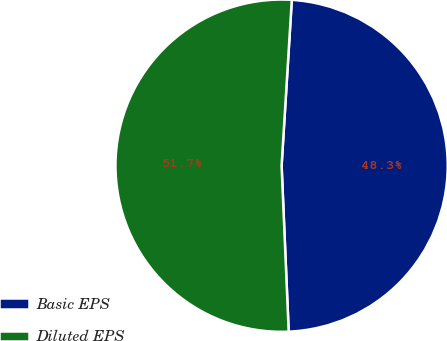Convert chart. <chart><loc_0><loc_0><loc_500><loc_500><pie_chart><fcel>Basic EPS<fcel>Diluted EPS<nl><fcel>48.34%<fcel>51.66%<nl></chart> 